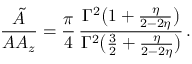Convert formula to latex. <formula><loc_0><loc_0><loc_500><loc_500>\frac { { \tilde { A } } } { A A _ { z } } = \frac { \pi } { 4 } \, \frac { \Gamma ^ { 2 } \left ( 1 + \frac { \eta } { 2 - 2 \eta } \right ) } { \Gamma ^ { 2 } \left ( \frac { 3 } { 2 } + \frac { \eta } { 2 - 2 \eta } \right ) } \, .</formula> 